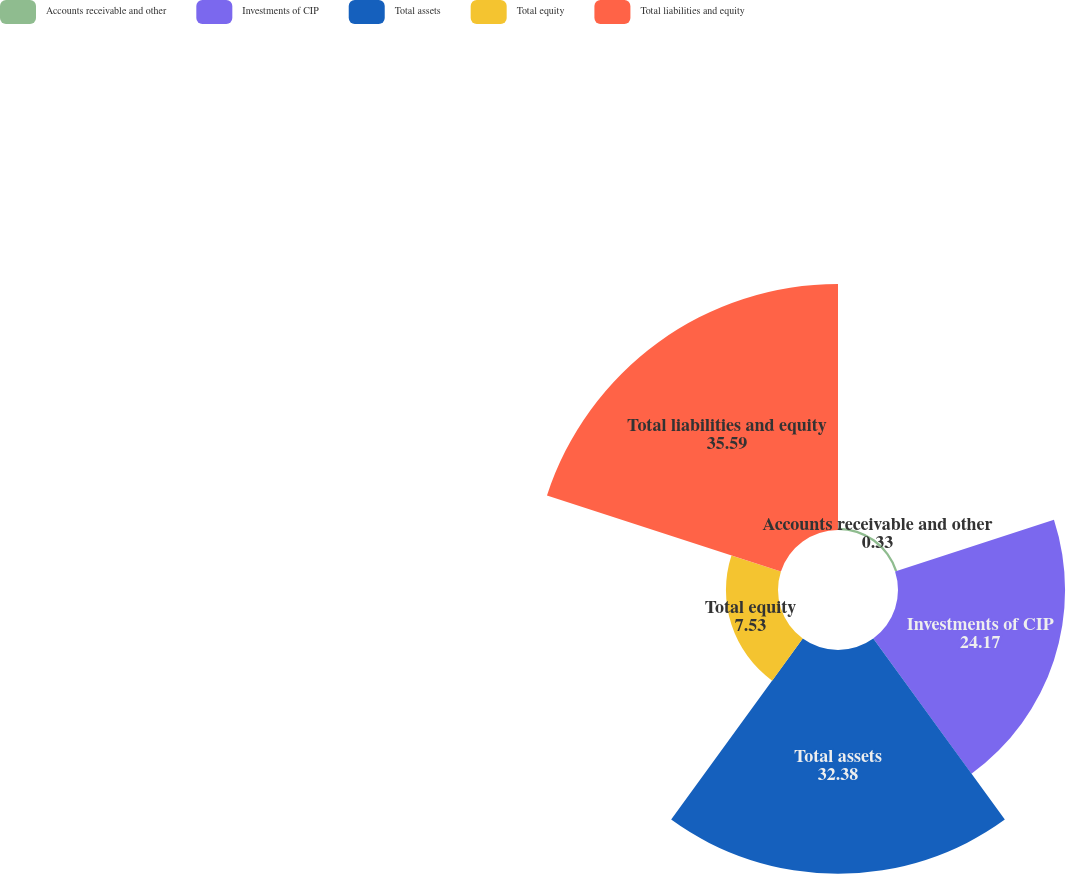<chart> <loc_0><loc_0><loc_500><loc_500><pie_chart><fcel>Accounts receivable and other<fcel>Investments of CIP<fcel>Total assets<fcel>Total equity<fcel>Total liabilities and equity<nl><fcel>0.33%<fcel>24.17%<fcel>32.38%<fcel>7.53%<fcel>35.59%<nl></chart> 